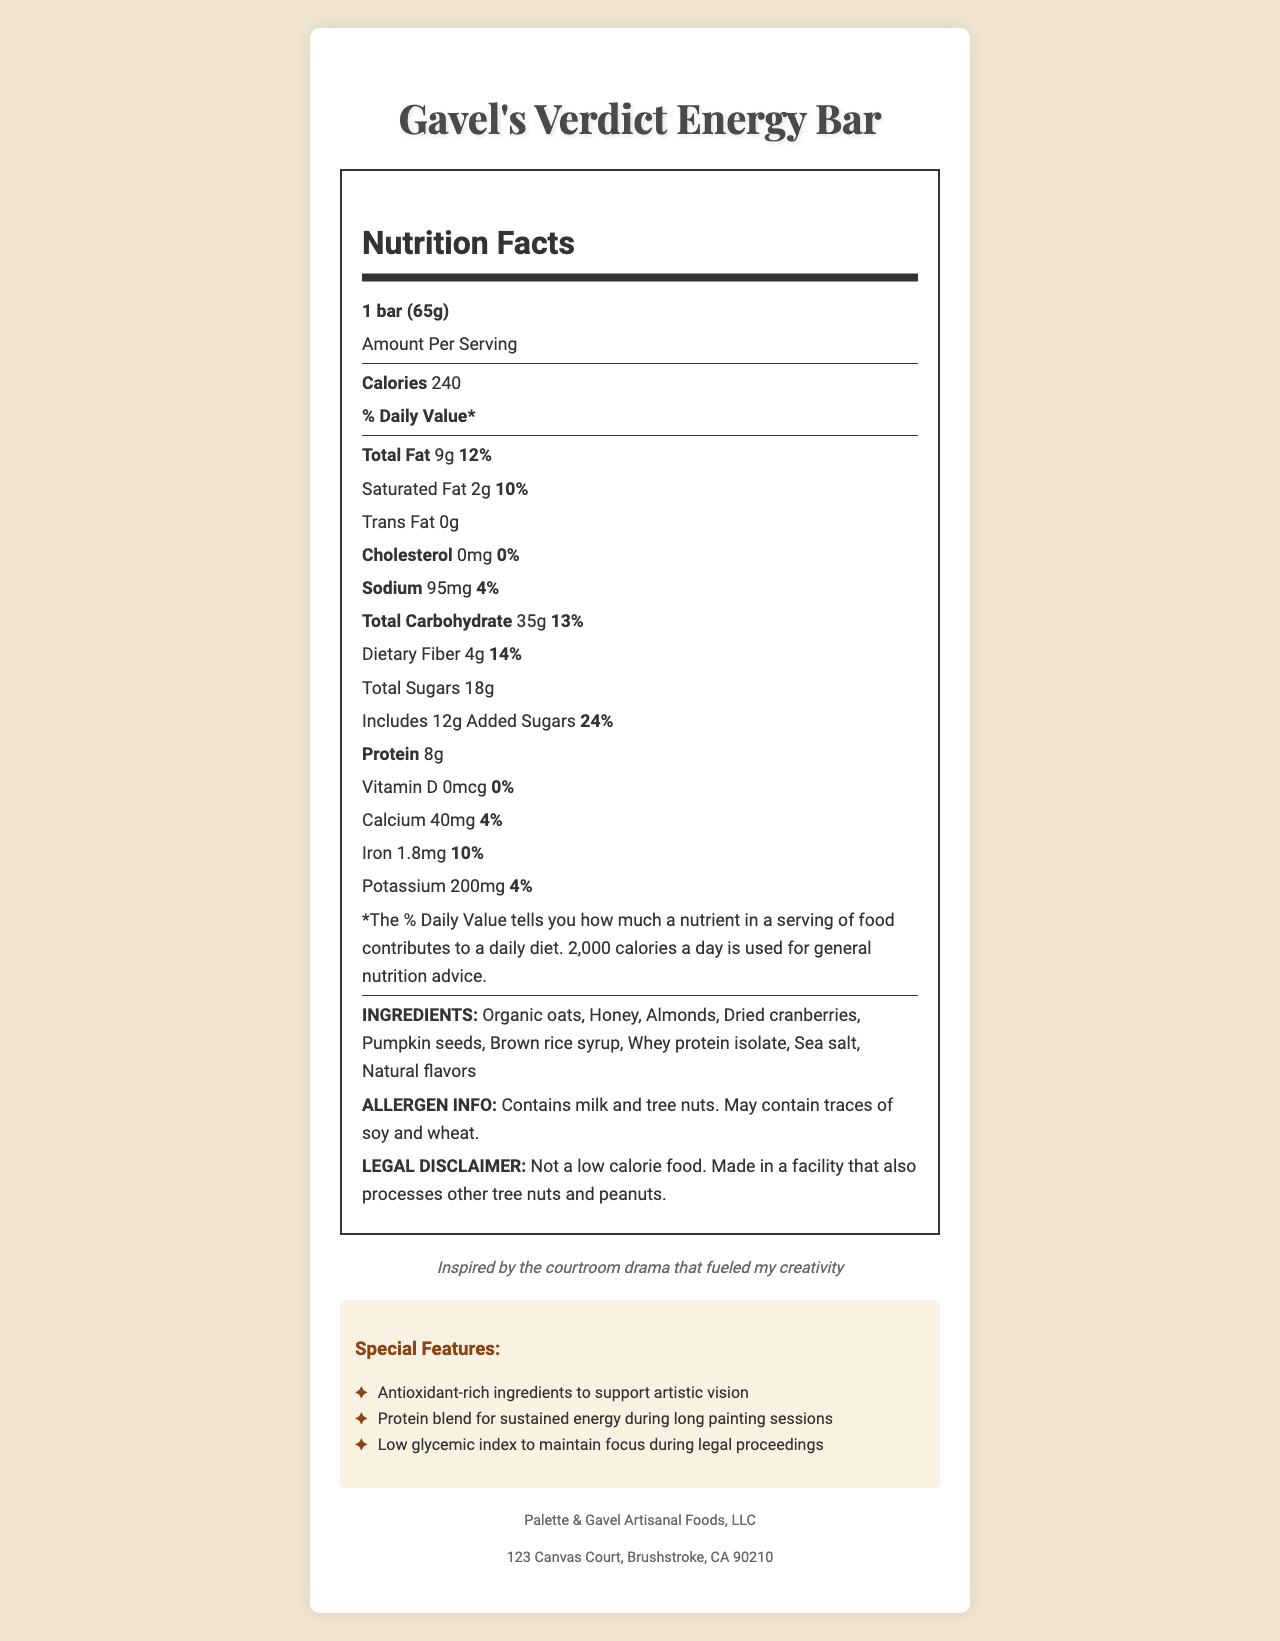what is the serving size? The serving size is specified at the top of the nutrition label as "1 bar (65g)".
Answer: 1 bar (65g) How many calories are in one serving of Gavel's Verdict Energy Bar? The document lists the calories in bold as 240 for one serving.
Answer: 240 What is the total fat content per serving? The total fat amount is indicated as 9g with a daily value of 12%.
Answer: 9g How much protein is in one bar? Under the nutrition information, protein is listed as 8g.
Answer: 8g What percentage of your daily value of added sugars is in one bar? The daily value percentage for added sugars is stated as 24%.
Answer: 24% What special features are highlighted for the Gavel's Verdict Energy Bar? The special features are listed under a section titled "Special Features" in the document.
Answer: Antioxidant-rich ingredients to support artistic vision, Protein blend for sustained energy during long painting sessions, Low glycemic index to maintain focus during legal proceedings Which ingredient provides the primary source of protein in the bar? A. Almonds B. Honey C. Whey protein isolate D. Pumpkin seeds Whey protein isolate is the most direct source of protein listed in the ingredients.
Answer: C What is the daily value percentage of dietary fiber? 1. 4% 2. 14% 3. 12% 4. 10% The document lists dietary fiber amount as 4g and the daily value as 14%.
Answer: 2 Does Gavel's Verdict Energy Bar contain any trans fat? The nutrition label explicitly states that it contains 0g of trans fat.
Answer: No Summarize the main idea of the document. The nutrition facts label provides comprehensive information about the energy bar’s nutritional contents per serving, lists ingredients, highlights special features for artistic and focus-related benefits, and includes manufacturer information.
Answer: The document is a nutrition facts label for the Gavel's Verdict Energy Bar, detailing its nutritional contents, ingredients, allergen information, legal disclaimer, special features, and manufacturer details. What motivated the artist to create this energy bar? The document does not provide enough information about the artist's motivation aside from an artist note that says it was "inspired by the courtroom drama that fueled my creativity." More context is needed to fully understand the artist’s motivation.
Answer: I don't know 